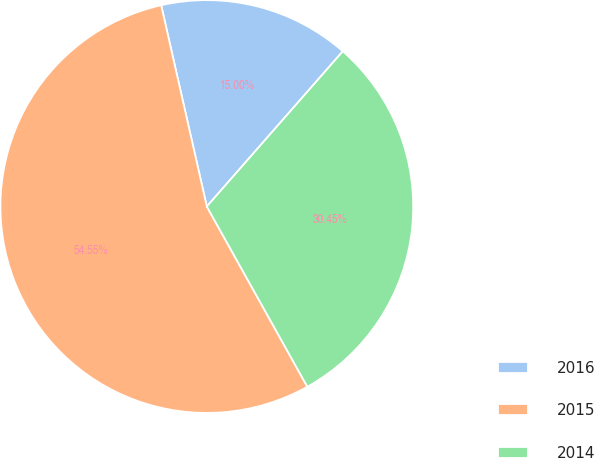Convert chart. <chart><loc_0><loc_0><loc_500><loc_500><pie_chart><fcel>2016<fcel>2015<fcel>2014<nl><fcel>15.0%<fcel>54.55%<fcel>30.45%<nl></chart> 